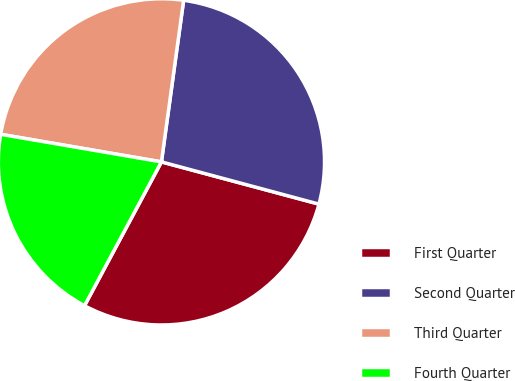Convert chart to OTSL. <chart><loc_0><loc_0><loc_500><loc_500><pie_chart><fcel>First Quarter<fcel>Second Quarter<fcel>Third Quarter<fcel>Fourth Quarter<nl><fcel>28.65%<fcel>27.0%<fcel>24.47%<fcel>19.89%<nl></chart> 